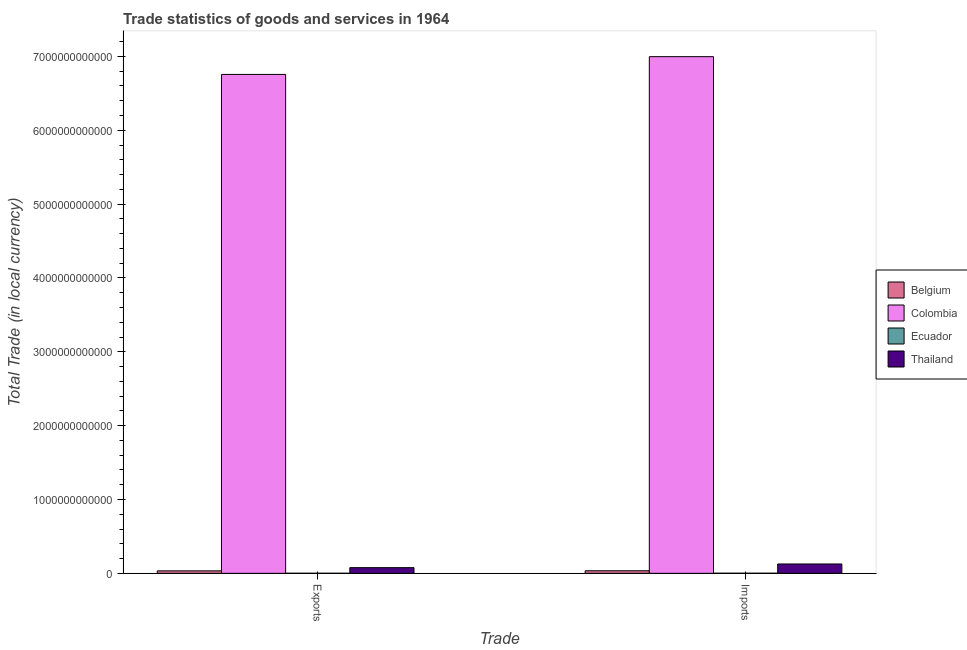How many bars are there on the 2nd tick from the right?
Offer a terse response. 4. What is the label of the 2nd group of bars from the left?
Your answer should be compact. Imports. What is the imports of goods and services in Belgium?
Your response must be concise. 3.47e+1. Across all countries, what is the maximum export of goods and services?
Provide a short and direct response. 6.76e+12. Across all countries, what is the minimum export of goods and services?
Your answer should be compact. 1.07e+09. In which country was the export of goods and services maximum?
Offer a terse response. Colombia. In which country was the export of goods and services minimum?
Your answer should be very brief. Ecuador. What is the total imports of goods and services in the graph?
Provide a short and direct response. 7.16e+12. What is the difference between the imports of goods and services in Ecuador and that in Thailand?
Ensure brevity in your answer.  -1.25e+11. What is the difference between the export of goods and services in Colombia and the imports of goods and services in Belgium?
Keep it short and to the point. 6.72e+12. What is the average export of goods and services per country?
Provide a succinct answer. 1.72e+12. What is the difference between the imports of goods and services and export of goods and services in Colombia?
Your answer should be compact. 2.41e+11. In how many countries, is the export of goods and services greater than 1600000000000 LCU?
Make the answer very short. 1. What is the ratio of the imports of goods and services in Belgium to that in Thailand?
Your answer should be compact. 0.27. Is the export of goods and services in Colombia less than that in Belgium?
Make the answer very short. No. In how many countries, is the imports of goods and services greater than the average imports of goods and services taken over all countries?
Offer a very short reply. 1. What does the 4th bar from the left in Imports represents?
Offer a very short reply. Thailand. How many bars are there?
Make the answer very short. 8. What is the difference between two consecutive major ticks on the Y-axis?
Provide a succinct answer. 1.00e+12. What is the title of the graph?
Your answer should be very brief. Trade statistics of goods and services in 1964. What is the label or title of the X-axis?
Make the answer very short. Trade. What is the label or title of the Y-axis?
Offer a terse response. Total Trade (in local currency). What is the Total Trade (in local currency) in Belgium in Exports?
Make the answer very short. 3.33e+1. What is the Total Trade (in local currency) of Colombia in Exports?
Your answer should be compact. 6.76e+12. What is the Total Trade (in local currency) in Ecuador in Exports?
Ensure brevity in your answer.  1.07e+09. What is the Total Trade (in local currency) of Thailand in Exports?
Ensure brevity in your answer.  7.70e+1. What is the Total Trade (in local currency) of Belgium in Imports?
Your answer should be very brief. 3.47e+1. What is the Total Trade (in local currency) of Colombia in Imports?
Your response must be concise. 7.00e+12. What is the Total Trade (in local currency) of Ecuador in Imports?
Keep it short and to the point. 1.53e+09. What is the Total Trade (in local currency) of Thailand in Imports?
Your answer should be very brief. 1.27e+11. Across all Trade, what is the maximum Total Trade (in local currency) in Belgium?
Make the answer very short. 3.47e+1. Across all Trade, what is the maximum Total Trade (in local currency) of Colombia?
Keep it short and to the point. 7.00e+12. Across all Trade, what is the maximum Total Trade (in local currency) of Ecuador?
Your response must be concise. 1.53e+09. Across all Trade, what is the maximum Total Trade (in local currency) of Thailand?
Your answer should be compact. 1.27e+11. Across all Trade, what is the minimum Total Trade (in local currency) of Belgium?
Make the answer very short. 3.33e+1. Across all Trade, what is the minimum Total Trade (in local currency) in Colombia?
Make the answer very short. 6.76e+12. Across all Trade, what is the minimum Total Trade (in local currency) of Ecuador?
Ensure brevity in your answer.  1.07e+09. Across all Trade, what is the minimum Total Trade (in local currency) in Thailand?
Ensure brevity in your answer.  7.70e+1. What is the total Total Trade (in local currency) in Belgium in the graph?
Provide a succinct answer. 6.80e+1. What is the total Total Trade (in local currency) of Colombia in the graph?
Provide a short and direct response. 1.38e+13. What is the total Total Trade (in local currency) in Ecuador in the graph?
Your answer should be compact. 2.61e+09. What is the total Total Trade (in local currency) of Thailand in the graph?
Your response must be concise. 2.04e+11. What is the difference between the Total Trade (in local currency) of Belgium in Exports and that in Imports?
Ensure brevity in your answer.  -1.45e+09. What is the difference between the Total Trade (in local currency) in Colombia in Exports and that in Imports?
Keep it short and to the point. -2.41e+11. What is the difference between the Total Trade (in local currency) of Ecuador in Exports and that in Imports?
Offer a very short reply. -4.64e+08. What is the difference between the Total Trade (in local currency) in Thailand in Exports and that in Imports?
Your answer should be very brief. -4.96e+1. What is the difference between the Total Trade (in local currency) in Belgium in Exports and the Total Trade (in local currency) in Colombia in Imports?
Your answer should be very brief. -6.96e+12. What is the difference between the Total Trade (in local currency) of Belgium in Exports and the Total Trade (in local currency) of Ecuador in Imports?
Give a very brief answer. 3.18e+1. What is the difference between the Total Trade (in local currency) in Belgium in Exports and the Total Trade (in local currency) in Thailand in Imports?
Give a very brief answer. -9.33e+1. What is the difference between the Total Trade (in local currency) in Colombia in Exports and the Total Trade (in local currency) in Ecuador in Imports?
Your answer should be very brief. 6.75e+12. What is the difference between the Total Trade (in local currency) in Colombia in Exports and the Total Trade (in local currency) in Thailand in Imports?
Your response must be concise. 6.63e+12. What is the difference between the Total Trade (in local currency) of Ecuador in Exports and the Total Trade (in local currency) of Thailand in Imports?
Keep it short and to the point. -1.26e+11. What is the average Total Trade (in local currency) of Belgium per Trade?
Ensure brevity in your answer.  3.40e+1. What is the average Total Trade (in local currency) of Colombia per Trade?
Offer a very short reply. 6.88e+12. What is the average Total Trade (in local currency) of Ecuador per Trade?
Offer a very short reply. 1.30e+09. What is the average Total Trade (in local currency) of Thailand per Trade?
Provide a short and direct response. 1.02e+11. What is the difference between the Total Trade (in local currency) of Belgium and Total Trade (in local currency) of Colombia in Exports?
Make the answer very short. -6.72e+12. What is the difference between the Total Trade (in local currency) in Belgium and Total Trade (in local currency) in Ecuador in Exports?
Provide a succinct answer. 3.22e+1. What is the difference between the Total Trade (in local currency) of Belgium and Total Trade (in local currency) of Thailand in Exports?
Provide a succinct answer. -4.37e+1. What is the difference between the Total Trade (in local currency) in Colombia and Total Trade (in local currency) in Ecuador in Exports?
Ensure brevity in your answer.  6.75e+12. What is the difference between the Total Trade (in local currency) in Colombia and Total Trade (in local currency) in Thailand in Exports?
Your answer should be very brief. 6.68e+12. What is the difference between the Total Trade (in local currency) of Ecuador and Total Trade (in local currency) of Thailand in Exports?
Provide a succinct answer. -7.59e+1. What is the difference between the Total Trade (in local currency) in Belgium and Total Trade (in local currency) in Colombia in Imports?
Offer a terse response. -6.96e+12. What is the difference between the Total Trade (in local currency) in Belgium and Total Trade (in local currency) in Ecuador in Imports?
Offer a terse response. 3.32e+1. What is the difference between the Total Trade (in local currency) in Belgium and Total Trade (in local currency) in Thailand in Imports?
Provide a short and direct response. -9.18e+1. What is the difference between the Total Trade (in local currency) of Colombia and Total Trade (in local currency) of Ecuador in Imports?
Your response must be concise. 6.99e+12. What is the difference between the Total Trade (in local currency) of Colombia and Total Trade (in local currency) of Thailand in Imports?
Your answer should be very brief. 6.87e+12. What is the difference between the Total Trade (in local currency) of Ecuador and Total Trade (in local currency) of Thailand in Imports?
Give a very brief answer. -1.25e+11. What is the ratio of the Total Trade (in local currency) of Belgium in Exports to that in Imports?
Provide a succinct answer. 0.96. What is the ratio of the Total Trade (in local currency) in Colombia in Exports to that in Imports?
Keep it short and to the point. 0.97. What is the ratio of the Total Trade (in local currency) of Ecuador in Exports to that in Imports?
Ensure brevity in your answer.  0.7. What is the ratio of the Total Trade (in local currency) in Thailand in Exports to that in Imports?
Provide a short and direct response. 0.61. What is the difference between the highest and the second highest Total Trade (in local currency) in Belgium?
Keep it short and to the point. 1.45e+09. What is the difference between the highest and the second highest Total Trade (in local currency) in Colombia?
Offer a terse response. 2.41e+11. What is the difference between the highest and the second highest Total Trade (in local currency) in Ecuador?
Offer a very short reply. 4.64e+08. What is the difference between the highest and the second highest Total Trade (in local currency) of Thailand?
Offer a terse response. 4.96e+1. What is the difference between the highest and the lowest Total Trade (in local currency) of Belgium?
Offer a very short reply. 1.45e+09. What is the difference between the highest and the lowest Total Trade (in local currency) of Colombia?
Offer a very short reply. 2.41e+11. What is the difference between the highest and the lowest Total Trade (in local currency) of Ecuador?
Your answer should be very brief. 4.64e+08. What is the difference between the highest and the lowest Total Trade (in local currency) in Thailand?
Provide a succinct answer. 4.96e+1. 